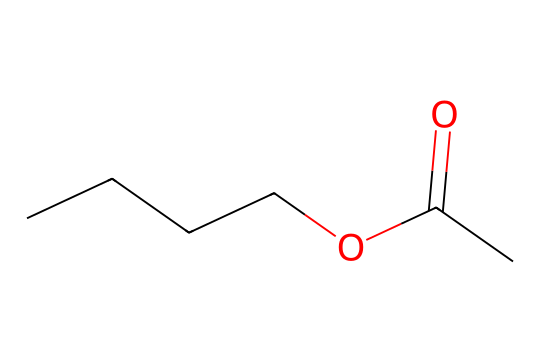how many carbon atoms are in butyl acetate? The SMILES representation shows four 'C' in the main chain and one 'C' in the ester group, totaling five carbon atoms.
Answer: five what type of bonding exists in butyl acetate? The chemical structure contains single bonds between the carbon atoms and a double bond between the carbon and oxygen in the ester functional group, indicating covalent bonding.
Answer: covalent what functional group is present in butyl acetate? The presence of the 'C(=O)O' segment in the structure indicates that butyl acetate contains an ester functional group.
Answer: ester how many oxygen atoms does butyl acetate have? The SMILES representation includes two 'O' atoms, one in the carbonyl group and one in the ester linkage, resulting in a total of two oxygen atoms.
Answer: two what is the molecular formula of butyl acetate? Analyzing the structure, we identify four carbon atoms from the butyl group, one carbon from the carbonyl, and two oxygen atoms, which gives us C5H10O2 as the molecular formula.
Answer: C5H10O2 is butyl acetate a hypervalent compound? In the structure, all atoms follow the octet rule, and there are no atoms that exceed eight valence electrons, thus butyl acetate is not classified as a hypervalent compound.
Answer: no 